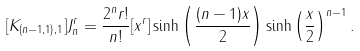<formula> <loc_0><loc_0><loc_500><loc_500>[ K _ { ( n - 1 , 1 ) , 1 } ] J _ { n } ^ { r } = \frac { 2 ^ { n } r ! } { n ! } [ x ^ { r } ] \sinh \left ( \frac { ( n - 1 ) x } { 2 } \right ) \sinh \left ( \frac { x } { 2 } \right ) ^ { n - 1 } .</formula> 